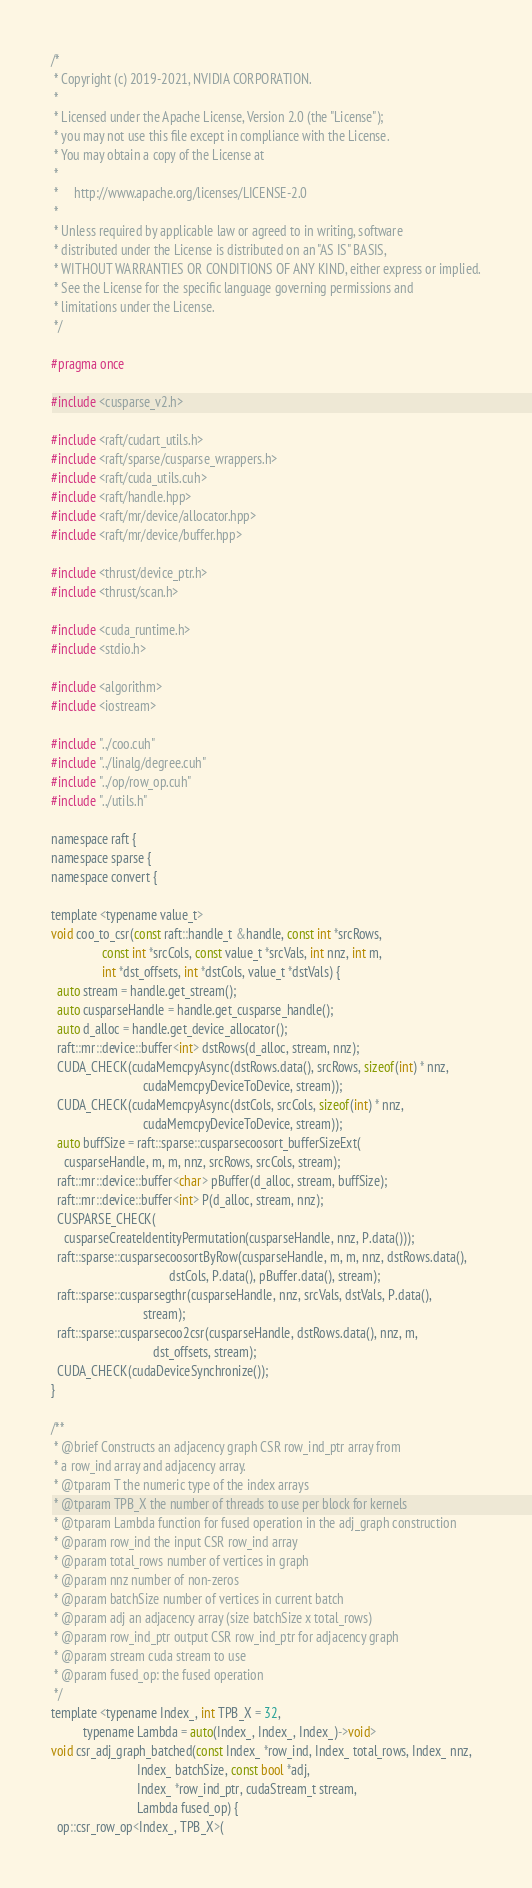Convert code to text. <code><loc_0><loc_0><loc_500><loc_500><_Cuda_>/*
 * Copyright (c) 2019-2021, NVIDIA CORPORATION.
 *
 * Licensed under the Apache License, Version 2.0 (the "License");
 * you may not use this file except in compliance with the License.
 * You may obtain a copy of the License at
 *
 *     http://www.apache.org/licenses/LICENSE-2.0
 *
 * Unless required by applicable law or agreed to in writing, software
 * distributed under the License is distributed on an "AS IS" BASIS,
 * WITHOUT WARRANTIES OR CONDITIONS OF ANY KIND, either express or implied.
 * See the License for the specific language governing permissions and
 * limitations under the License.
 */

#pragma once

#include <cusparse_v2.h>

#include <raft/cudart_utils.h>
#include <raft/sparse/cusparse_wrappers.h>
#include <raft/cuda_utils.cuh>
#include <raft/handle.hpp>
#include <raft/mr/device/allocator.hpp>
#include <raft/mr/device/buffer.hpp>

#include <thrust/device_ptr.h>
#include <thrust/scan.h>

#include <cuda_runtime.h>
#include <stdio.h>

#include <algorithm>
#include <iostream>

#include "../coo.cuh"
#include "../linalg/degree.cuh"
#include "../op/row_op.cuh"
#include "../utils.h"

namespace raft {
namespace sparse {
namespace convert {

template <typename value_t>
void coo_to_csr(const raft::handle_t &handle, const int *srcRows,
                const int *srcCols, const value_t *srcVals, int nnz, int m,
                int *dst_offsets, int *dstCols, value_t *dstVals) {
  auto stream = handle.get_stream();
  auto cusparseHandle = handle.get_cusparse_handle();
  auto d_alloc = handle.get_device_allocator();
  raft::mr::device::buffer<int> dstRows(d_alloc, stream, nnz);
  CUDA_CHECK(cudaMemcpyAsync(dstRows.data(), srcRows, sizeof(int) * nnz,
                             cudaMemcpyDeviceToDevice, stream));
  CUDA_CHECK(cudaMemcpyAsync(dstCols, srcCols, sizeof(int) * nnz,
                             cudaMemcpyDeviceToDevice, stream));
  auto buffSize = raft::sparse::cusparsecoosort_bufferSizeExt(
    cusparseHandle, m, m, nnz, srcRows, srcCols, stream);
  raft::mr::device::buffer<char> pBuffer(d_alloc, stream, buffSize);
  raft::mr::device::buffer<int> P(d_alloc, stream, nnz);
  CUSPARSE_CHECK(
    cusparseCreateIdentityPermutation(cusparseHandle, nnz, P.data()));
  raft::sparse::cusparsecoosortByRow(cusparseHandle, m, m, nnz, dstRows.data(),
                                     dstCols, P.data(), pBuffer.data(), stream);
  raft::sparse::cusparsegthr(cusparseHandle, nnz, srcVals, dstVals, P.data(),
                             stream);
  raft::sparse::cusparsecoo2csr(cusparseHandle, dstRows.data(), nnz, m,
                                dst_offsets, stream);
  CUDA_CHECK(cudaDeviceSynchronize());
}

/**
 * @brief Constructs an adjacency graph CSR row_ind_ptr array from
 * a row_ind array and adjacency array.
 * @tparam T the numeric type of the index arrays
 * @tparam TPB_X the number of threads to use per block for kernels
 * @tparam Lambda function for fused operation in the adj_graph construction
 * @param row_ind the input CSR row_ind array
 * @param total_rows number of vertices in graph
 * @param nnz number of non-zeros
 * @param batchSize number of vertices in current batch
 * @param adj an adjacency array (size batchSize x total_rows)
 * @param row_ind_ptr output CSR row_ind_ptr for adjacency graph
 * @param stream cuda stream to use
 * @param fused_op: the fused operation
 */
template <typename Index_, int TPB_X = 32,
          typename Lambda = auto(Index_, Index_, Index_)->void>
void csr_adj_graph_batched(const Index_ *row_ind, Index_ total_rows, Index_ nnz,
                           Index_ batchSize, const bool *adj,
                           Index_ *row_ind_ptr, cudaStream_t stream,
                           Lambda fused_op) {
  op::csr_row_op<Index_, TPB_X>(</code> 